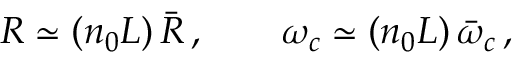<formula> <loc_0><loc_0><loc_500><loc_500>R \simeq ( n _ { 0 } L ) \, \bar { R } \, , \quad \omega _ { c } \simeq ( n _ { 0 } L ) \, \bar { \omega } _ { c } \, ,</formula> 